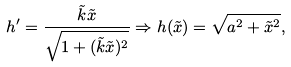<formula> <loc_0><loc_0><loc_500><loc_500>h ^ { \prime } = \frac { \tilde { k } \tilde { x } } { \sqrt { 1 + ( \tilde { k } \tilde { x } ) ^ { 2 } } } \Rightarrow h ( \tilde { x } ) = \sqrt { a ^ { 2 } + \tilde { x } ^ { 2 } } ,</formula> 